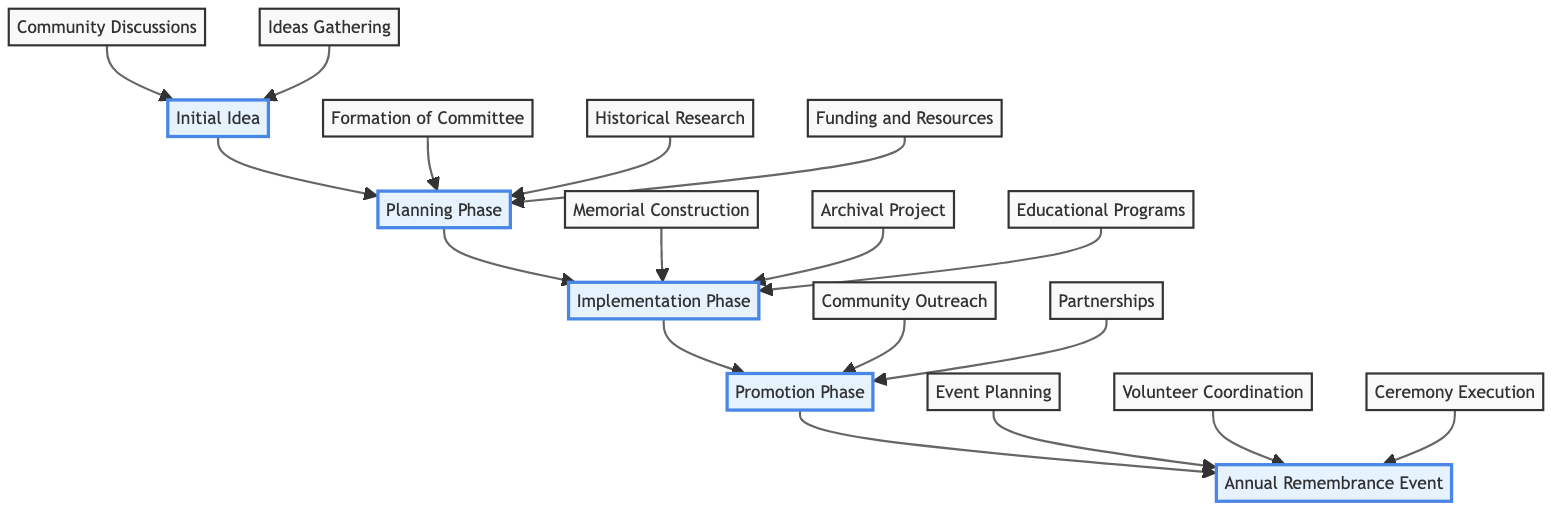What is the final output of the diagram's flow? The flowchart culminates in the "Annual Remembrance Event," which is the ultimate goal of the community efforts to preserve war memories. This node is positioned at the top of the diagram, indicating it is the endpoint of the flow.
Answer: Annual Remembrance Event How many phases are there in the diagram? The diagram comprises five distinct phases, namely "Initial Idea," "Planning Phase," "Implementation Phase," "Promotion Phase," and "Annual Remembrance Event."
Answer: 5 What follows the "Promotion Phase"? "Annual Remembrance Event" comes after the "Promotion Phase" in the upward flow, indicating that it directly follows the efforts made in the previous phase.
Answer: Annual Remembrance Event What is one activity described in the "Implementation Phase"? The node under the "Implementation Phase" indicates "Memorial Construction," signifying one of the key activities undertaken to preserve war memories.
Answer: Memorial Construction How does the "Planning Phase" connect to the "Implementation Phase"? The "Planning Phase" leads directly to the "Implementation Phase," showing that the planning activities, such as forming a committee and conducting historical research, facilitate the eventual implementation of community efforts.
Answer: Direct connection What is the purpose of the "Heritage Preservation Committee"? The "Heritage Preservation Committee" is formed in the planning phase to coordinate the community's efforts and ensure organized actions are taken toward preserving war memories.
Answer: Coordination of efforts Which node is involved in gathering ideas? The "Ideas Gathering" node in the "Initial Idea" phase pertains specifically to collecting ideas from both elders and youth regarding the preservation of war memories.
Answer: Ideas Gathering What is one of the includes in the "Community Outreach"? "Community Outreach" in the "Promotion Phase" involves engaging the local community through local media and social networks to raise awareness about the remembrance event and preservation efforts.
Answer: Engaging the community How do the "Community Discussions" and "Ideas Gathering" relate? Both "Community Discussions" and "Ideas Gathering" are initial activities under the "Initial Idea" phase, indicating that they jointly contribute to the foundational discussions on how to preserve war memories before any formal actions are taken.
Answer: Joint contribution 